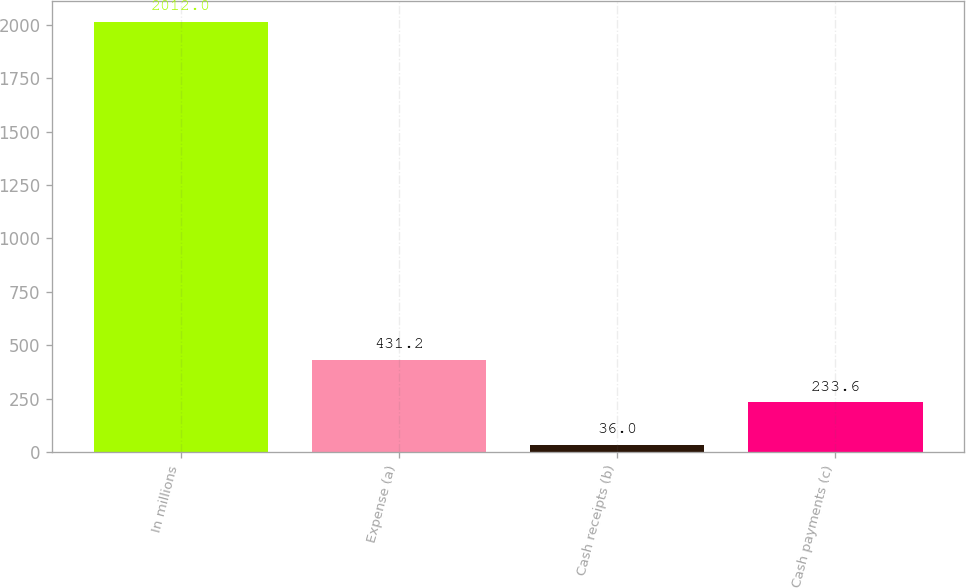Convert chart to OTSL. <chart><loc_0><loc_0><loc_500><loc_500><bar_chart><fcel>In millions<fcel>Expense (a)<fcel>Cash receipts (b)<fcel>Cash payments (c)<nl><fcel>2012<fcel>431.2<fcel>36<fcel>233.6<nl></chart> 